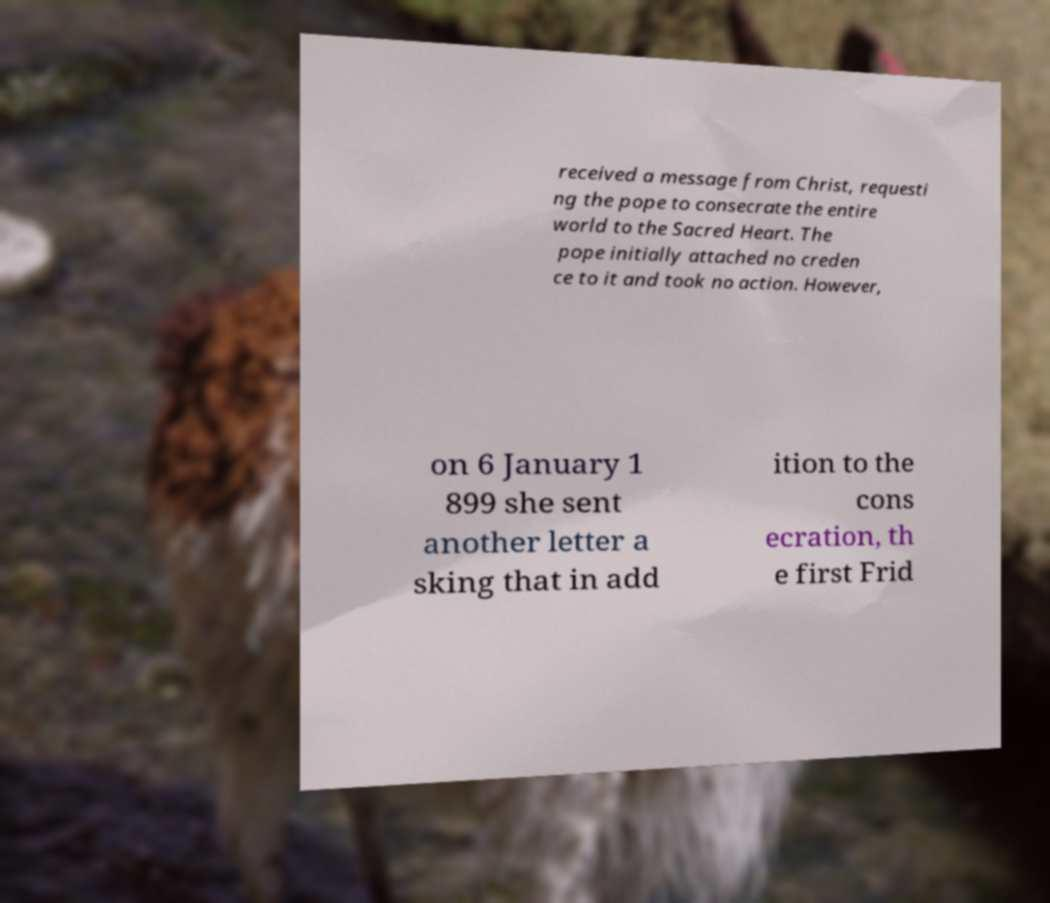Can you read and provide the text displayed in the image?This photo seems to have some interesting text. Can you extract and type it out for me? received a message from Christ, requesti ng the pope to consecrate the entire world to the Sacred Heart. The pope initially attached no creden ce to it and took no action. However, on 6 January 1 899 she sent another letter a sking that in add ition to the cons ecration, th e first Frid 